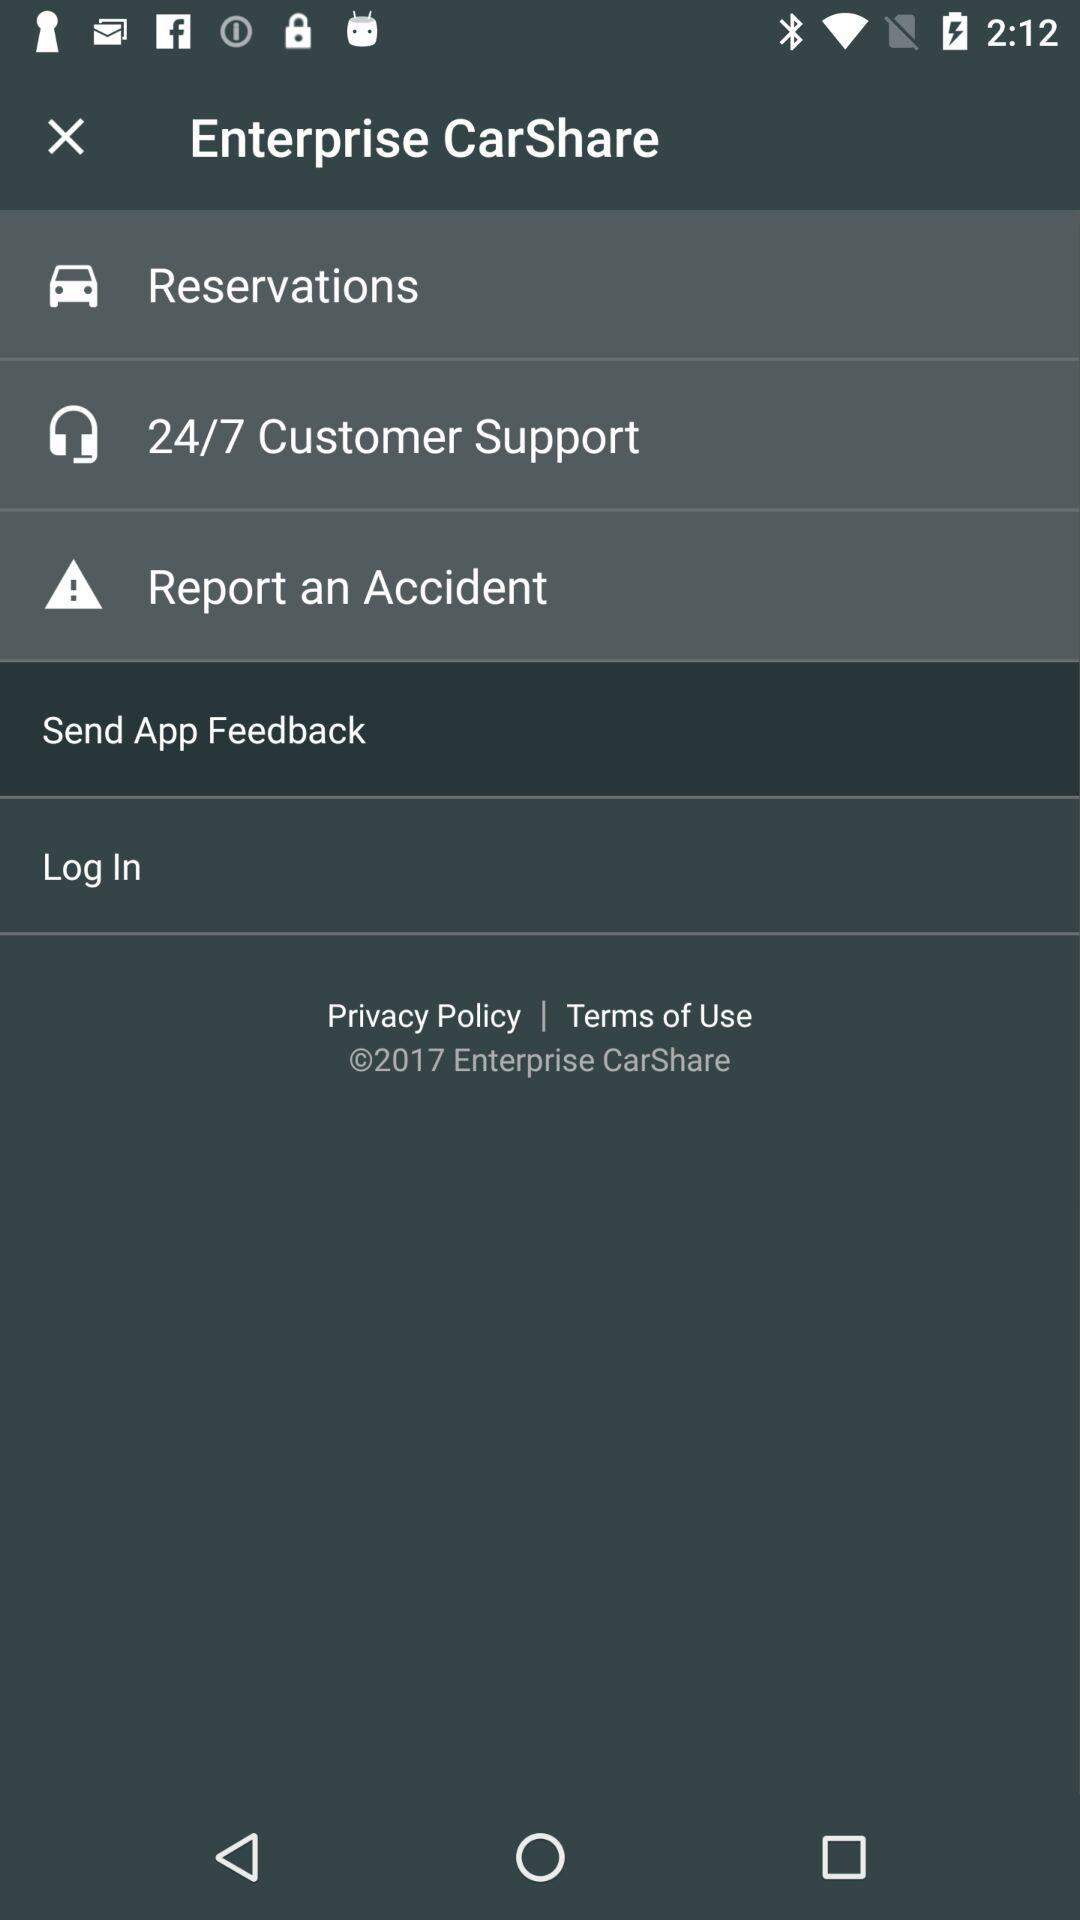What is the application name? The application name is "Enterprise CarShare". 